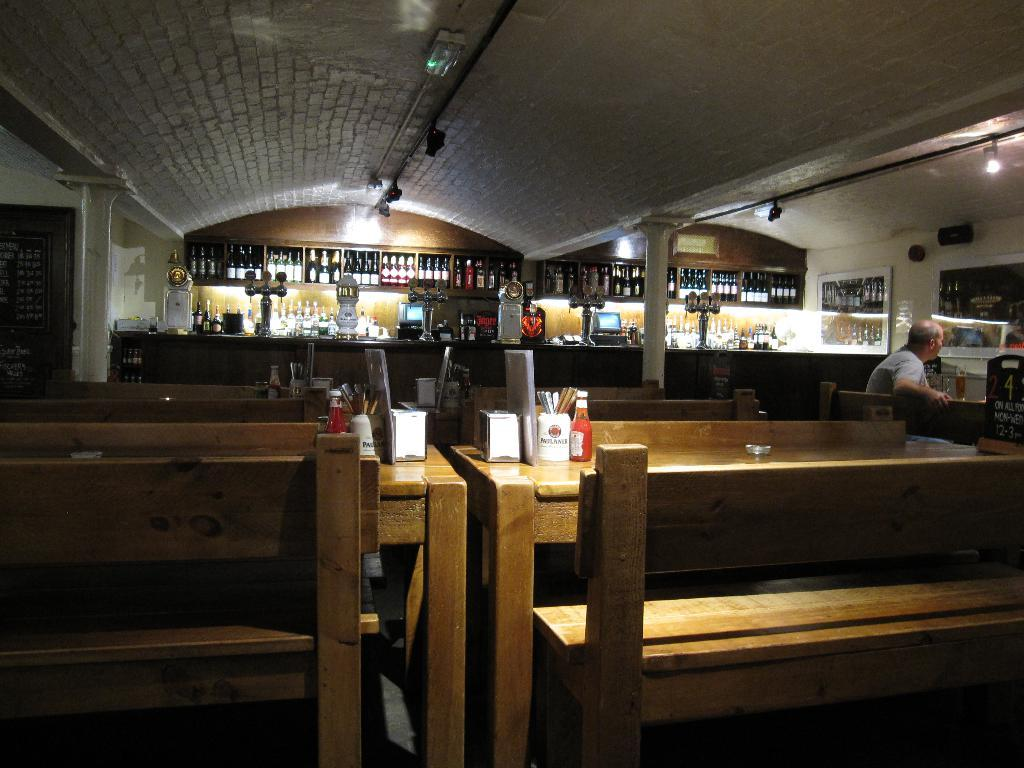What is present on the table in the image? There are glasses on the table in the image. What can be seen in the background of the image? There are bottles and monitors in the background of the image. What is the man in the image doing? The man is seated on a chair in the image. What is the sauce bottle used for? The sauce bottle is likely used for adding sauce to food. Can you see any ghosts in the image? There are no ghosts present in the image. Is the man in the image jumping? The man is seated on a chair, so he is not jumping in the image. 